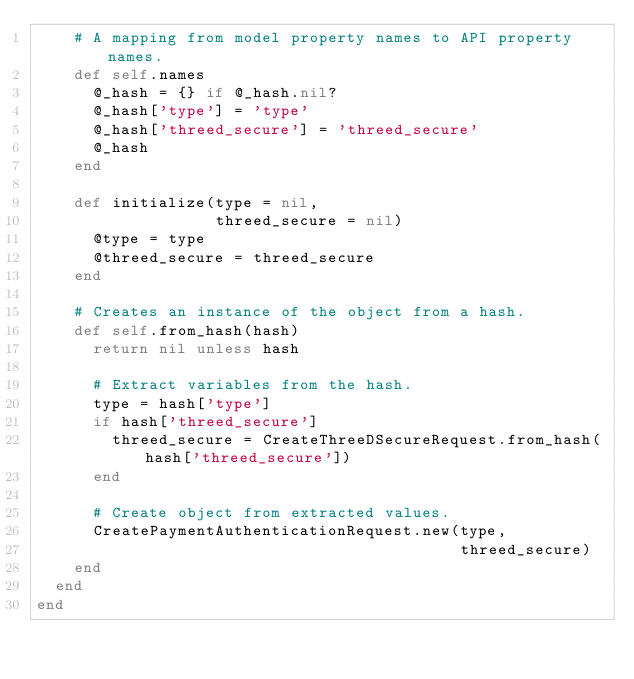<code> <loc_0><loc_0><loc_500><loc_500><_Ruby_>    # A mapping from model property names to API property names.
    def self.names
      @_hash = {} if @_hash.nil?
      @_hash['type'] = 'type'
      @_hash['threed_secure'] = 'threed_secure'
      @_hash
    end

    def initialize(type = nil,
                   threed_secure = nil)
      @type = type
      @threed_secure = threed_secure
    end

    # Creates an instance of the object from a hash.
    def self.from_hash(hash)
      return nil unless hash

      # Extract variables from the hash.
      type = hash['type']
      if hash['threed_secure']
        threed_secure = CreateThreeDSecureRequest.from_hash(hash['threed_secure'])
      end

      # Create object from extracted values.
      CreatePaymentAuthenticationRequest.new(type,
                                             threed_secure)
    end
  end
end
</code> 